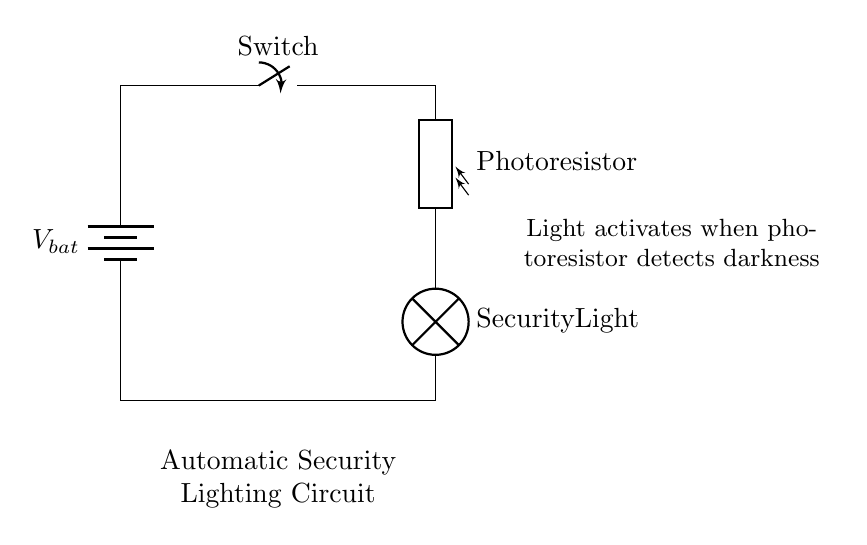What is the main function of the photoresistor in this circuit? The photoresistor detects light levels; it changes resistance based on light exposure, allowing light activation during darkness.
Answer: detect light levels What component controls the activation of the security light? The switch controls whether the circuit is complete or not, thus determining if the security light is activated when the photoresistor detects darkness.
Answer: switch Is this circuit series or parallel? The components are connected in a single path, meaning there is only one route for current flow, which classifies it as a series circuit.
Answer: series What type of component is used to provide power in this circuit? The circuit uses a battery, which supplies the necessary voltage and current to operate the rest of the components.
Answer: battery What happens to the security light when it gets dark? When it gets dark, the resistance of the photoresistor increases, allowing the circuit to close and the security light to turn on automatically.
Answer: turns on How many components are in this circuit? There are four main components: a battery, a switch, a photoresistor, and a security light, indicating the total number in the series.
Answer: four What is the role of the switch in this circuit? The switch allows for manual control of the circuit, enabling or disabling the flow of electricity to the security light, independent of the light sensor's response.
Answer: manual control 